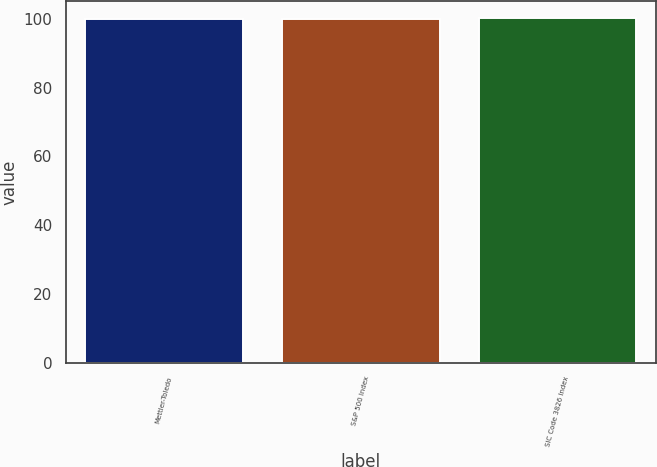Convert chart to OTSL. <chart><loc_0><loc_0><loc_500><loc_500><bar_chart><fcel>Mettler-Toledo<fcel>S&P 500 Index<fcel>SIC Code 3826 Index<nl><fcel>100<fcel>100.1<fcel>100.2<nl></chart> 